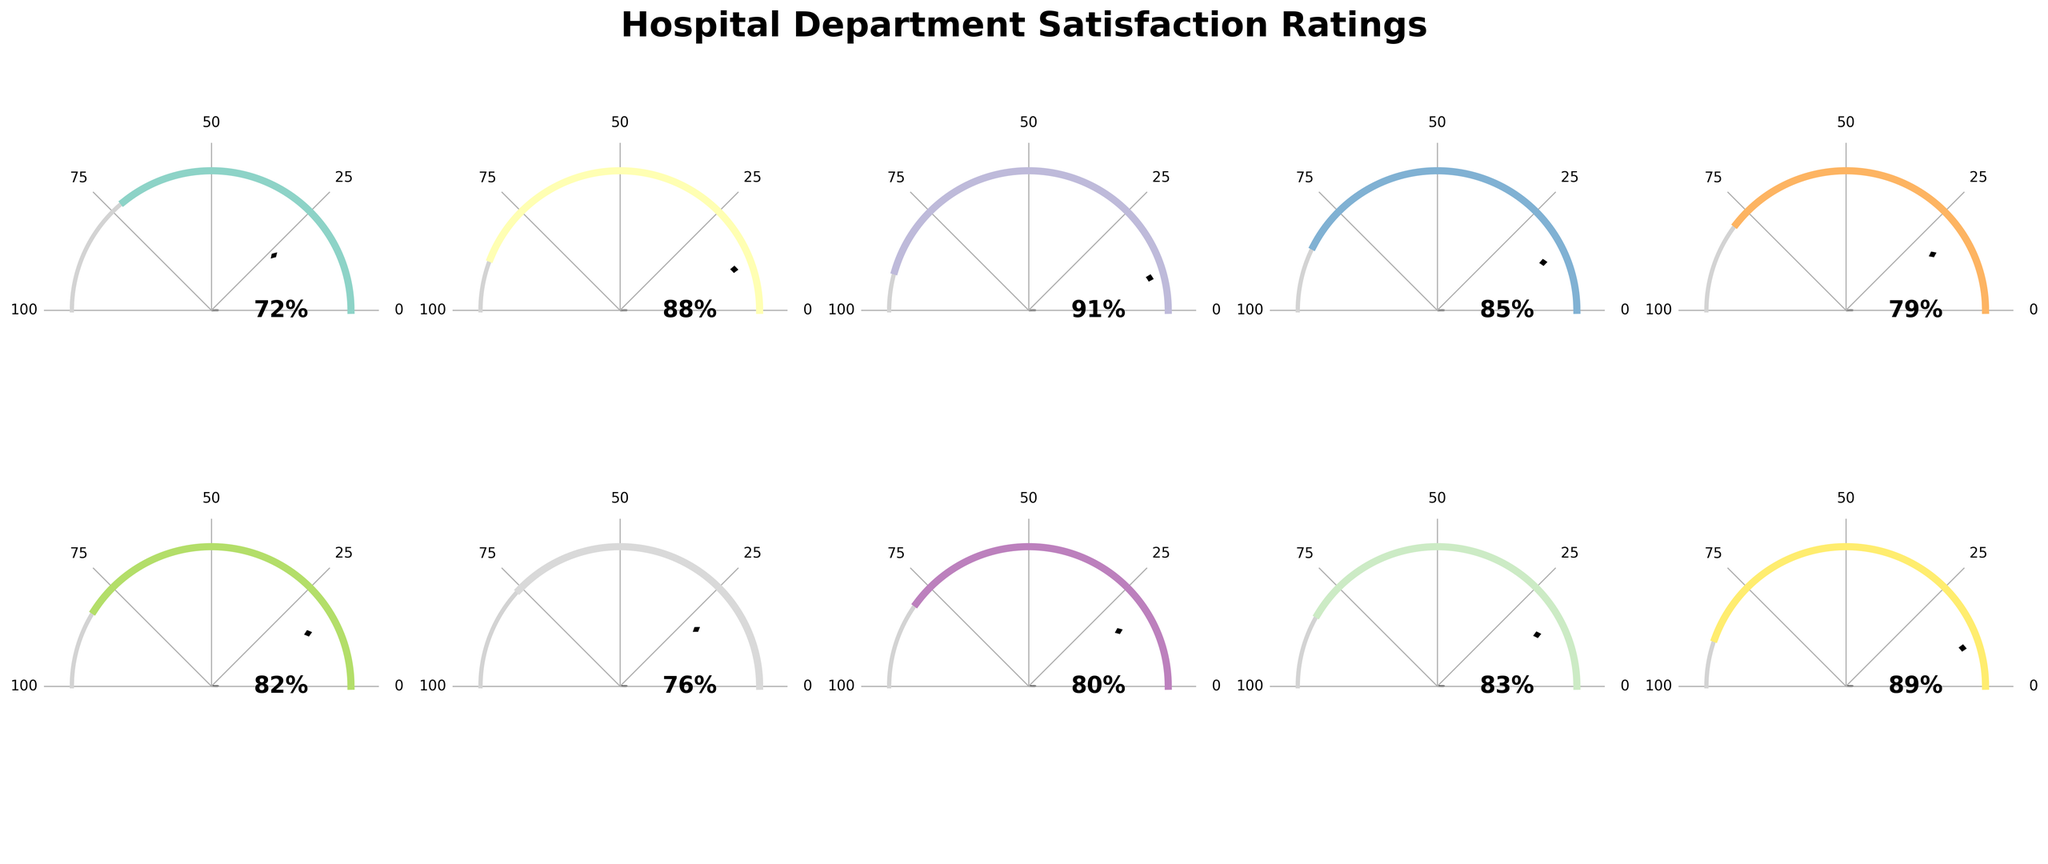Which department has the highest satisfaction rating? To determine the highest satisfaction rating, look at each gauge chart and identify which one has the rating closest to 100%. The Pediatrics department has the highest rating at 91%.
Answer: Pediatrics What's the title of the figure? The title is located at the top of the figure. It reads "Hospital Department Satisfaction Ratings".
Answer: Hospital Department Satisfaction Ratings How many departments have satisfaction ratings higher than 80%? By examining each gauge chart, count the number of departments where the satisfaction rating is above 80%. The departments are Cardiology, Pediatrics, Oncology, Neurology, General Surgery, and Obstetrics. This totals to 6 departments.
Answer: 6 Which department has the lowest satisfaction rating and what is it? Identify the gauge with the lowest filled portion. The Emergency Room has the lowest satisfaction rating at 72%.
Answer: Emergency Room, 72% What is the average satisfaction rating for all departments? Add up all the satisfaction ratings and divide by the number of departments. (72 + 88 + 91 + 85 + 79 + 82 + 76 + 80 + 83 + 89) / 10 = 82.5.
Answer: 82.5 Compare the satisfaction ratings of Neurology and Orthopedics. Which is higher and by how much? Neurology has a satisfaction rating of 82, while Orthopedics has a satisfaction rating of 79. Subtract 79 from 82 to find the difference. 82 - 79 = 3. Neurology's rating is higher by 3%.
Answer: Neurology by 3% Which department has a satisfaction rating closest to 75%? Review each gauge to find the department whose rating is closest to 75%. The Geriatrics department has a rating of 76%, which is closest to 75%.
Answer: Geriatrics What's the difference in satisfaction ratings between Oncology and General Surgery? Subtract the satisfaction rating of Oncology (85%) from General Surgery (83%). 85 - 83 = 2%.
Answer: 2% How many departments have satisfaction ratings below 80%? Count the departments that have satisfaction ratings below 80%. They are Emergency Room, Orthopedics, and Geriatrics, which totals to 3 departments.
Answer: 3 What is the median satisfaction rating of all departments? To find the median, list all ratings in ascending order (72, 76, 79, 80, 82, 83, 85, 88, 89, 91). The median is the average of the 5th and 6th values. (82 + 83) / 2 = 82.5.
Answer: 82.5 